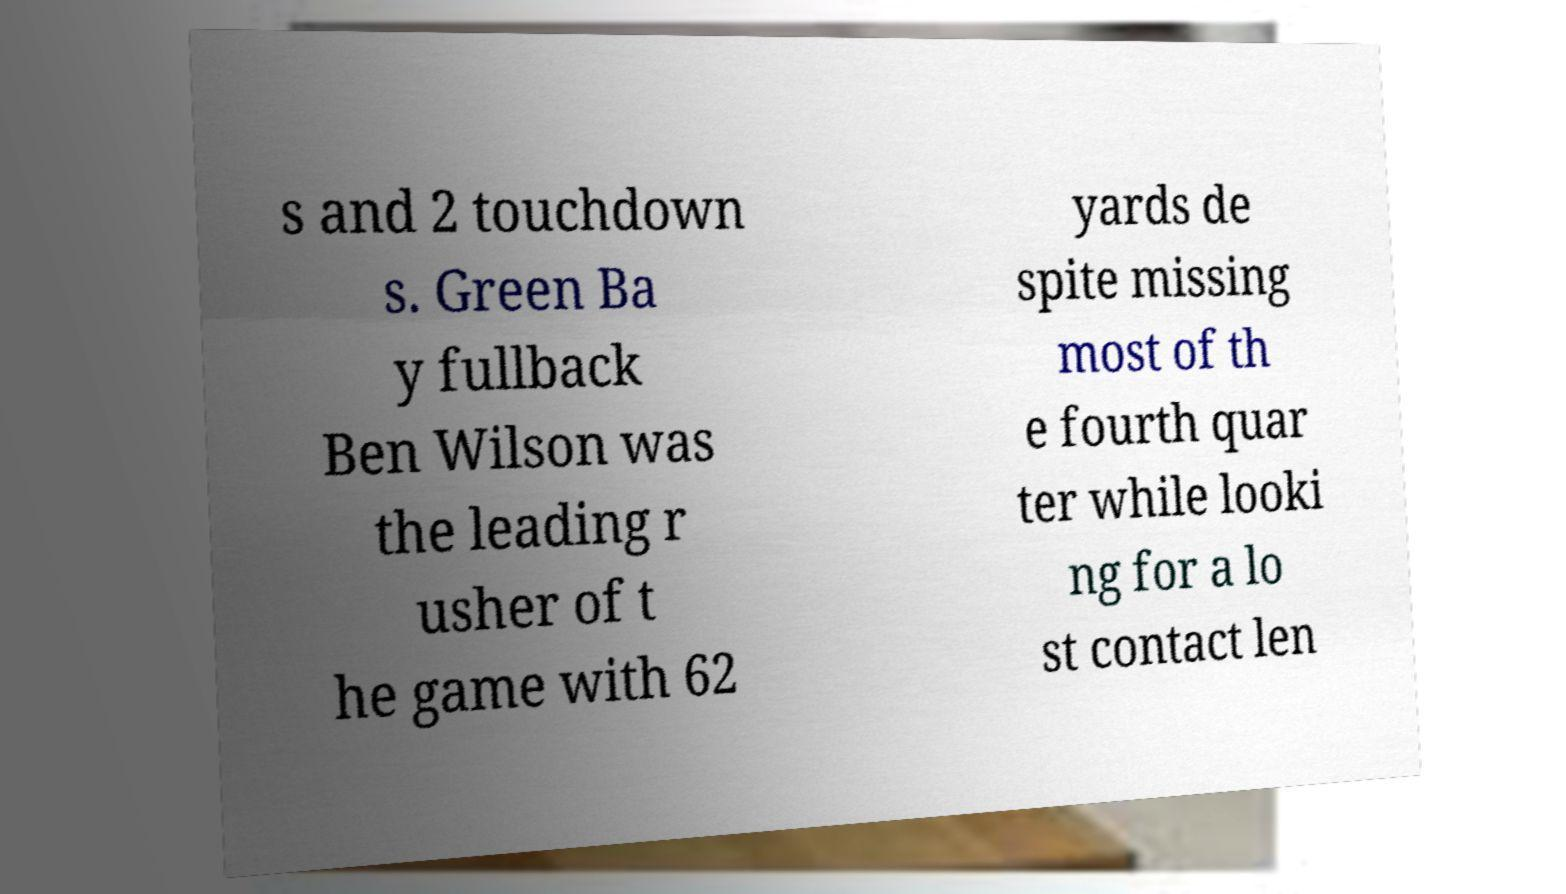For documentation purposes, I need the text within this image transcribed. Could you provide that? s and 2 touchdown s. Green Ba y fullback Ben Wilson was the leading r usher of t he game with 62 yards de spite missing most of th e fourth quar ter while looki ng for a lo st contact len 